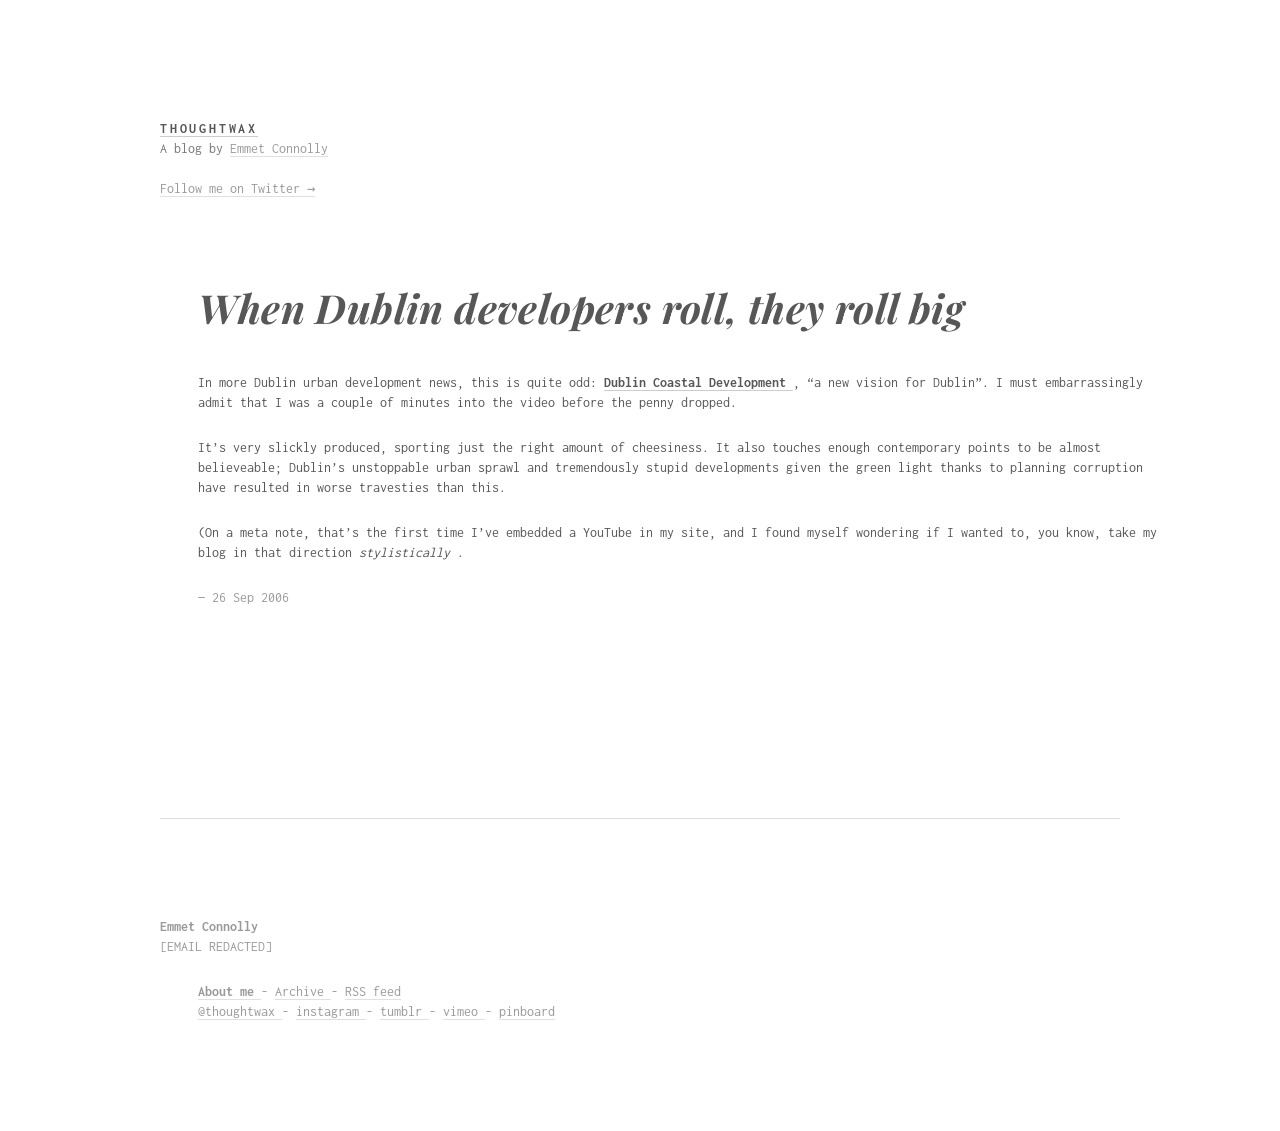Can you provide a basic HTML structure to start a blog like the one in the image? <!DOCTYPE html>
<html lang="en">
<head>
<meta charset="UTF-8">
<meta name="viewport" content="width=device-width, initial-scale=1.0">
<title>Simple Blog</title>
</head>
<body>
<header>
<h1>Blog Name</h1>
<p>Follow me on Twitter →</p>
</header>
<main>
<article>
<h2>Post Title</h2>
<p>Post content...</p>
</article>
</main>
<footer>
<p>About me - Archive - RSS feed</p>
</footer>
</body>
</html> 